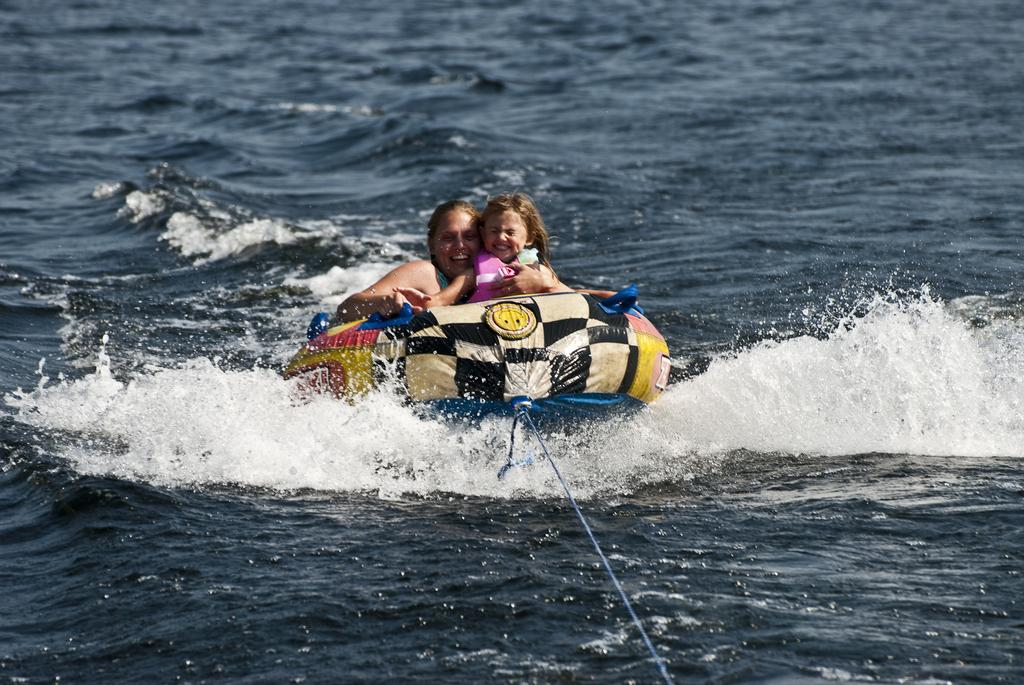What is at the bottom of the image? There is water at the bottom of the image. What can be seen in the middle of the image? There is an inflatable boat in the middle of the image. Who is present in the boat? A woman and a kid are in the boat. What type of unit is being used to measure the depth of the water in the image? There is no unit present in the image to measure the depth of the water. Can you see a cemetery in the background of the image? There is no cemetery visible in the image; it features water, an inflatable boat, and the people in the boat. 